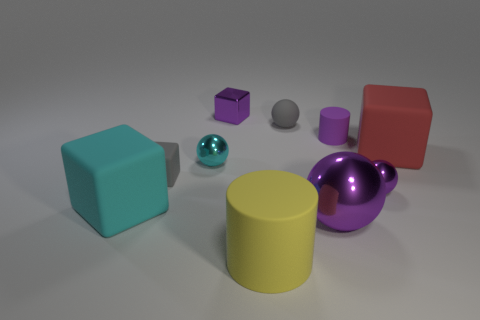Subtract all rubber blocks. How many blocks are left? 1 Subtract all balls. How many objects are left? 6 Add 3 big cylinders. How many big cylinders exist? 4 Subtract all red blocks. How many blocks are left? 3 Subtract 0 brown blocks. How many objects are left? 10 Subtract 1 spheres. How many spheres are left? 3 Subtract all blue balls. Subtract all gray cylinders. How many balls are left? 4 Subtract all purple cylinders. How many gray cubes are left? 1 Subtract all big purple shiny things. Subtract all metal cubes. How many objects are left? 8 Add 9 tiny metallic blocks. How many tiny metallic blocks are left? 10 